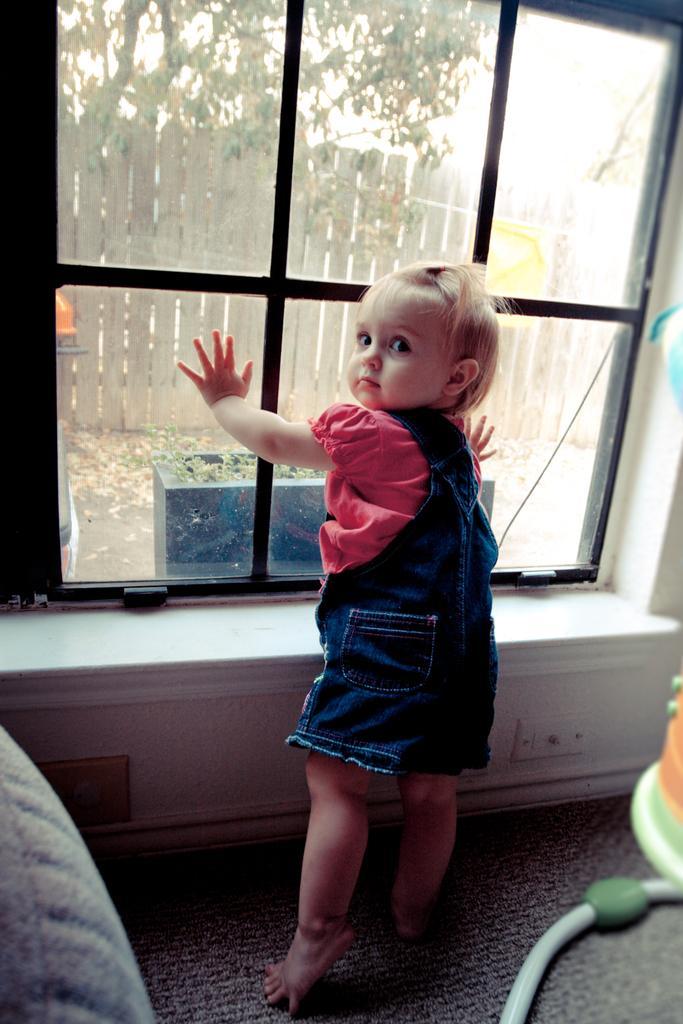Could you give a brief overview of what you see in this image? In this image in front there is a girl standing on the mat. In front of her there is a glass door through which we can see wooden fence, trees and a few other objects. On the right side of the image there is some object. On the left side of the image there is a couch. 